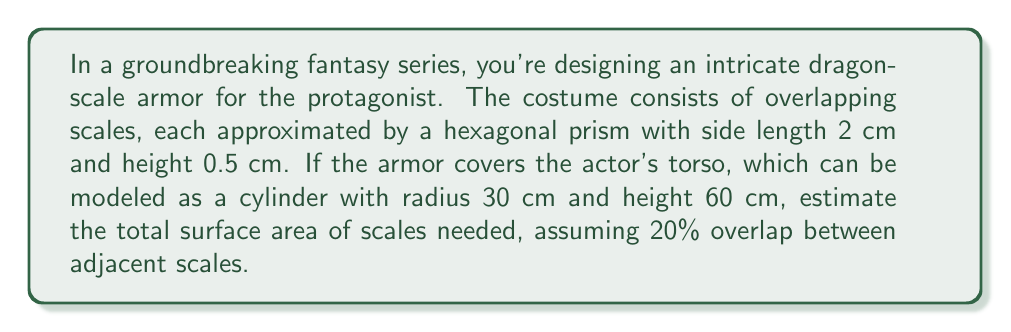Solve this math problem. Let's approach this step-by-step:

1) First, calculate the surface area of the torso cylinder:
   Lateral surface area: $2\pi r h = 2\pi(30)(60) = 3600\pi$ cm²
   Top and bottom circles: $2\pi r^2 = 2\pi(30)^2 = 1800\pi$ cm²
   Total cylinder surface area: $5400\pi$ cm²

2) Calculate the area of one hexagonal scale (top face):
   Area of a regular hexagon: $A = \frac{3\sqrt{3}}{2}a^2$, where $a$ is the side length
   $A = \frac{3\sqrt{3}}{2}(2)^2 = 6\sqrt{3}$ cm²

3) Calculate the number of scales needed:
   Cylinder surface area / (Scale area × (1 - overlap))
   $\frac{5400\pi}{6\sqrt{3} \times 0.8} \approx 487$ scales

4) Calculate total surface area of scales:
   For each scale, we need to account for the top face and 6 rectangular side faces
   Side face area: $2 \times 0.5 = 1$ cm²
   Total area per scale: $6\sqrt{3} + 6 = 6(\sqrt{3} + 1)$ cm²

5) Final calculation:
   Total surface area = Number of scales × Area per scale
   $487 \times 6(\sqrt{3} + 1) \approx 5052$ cm²
Answer: $5052$ cm² 